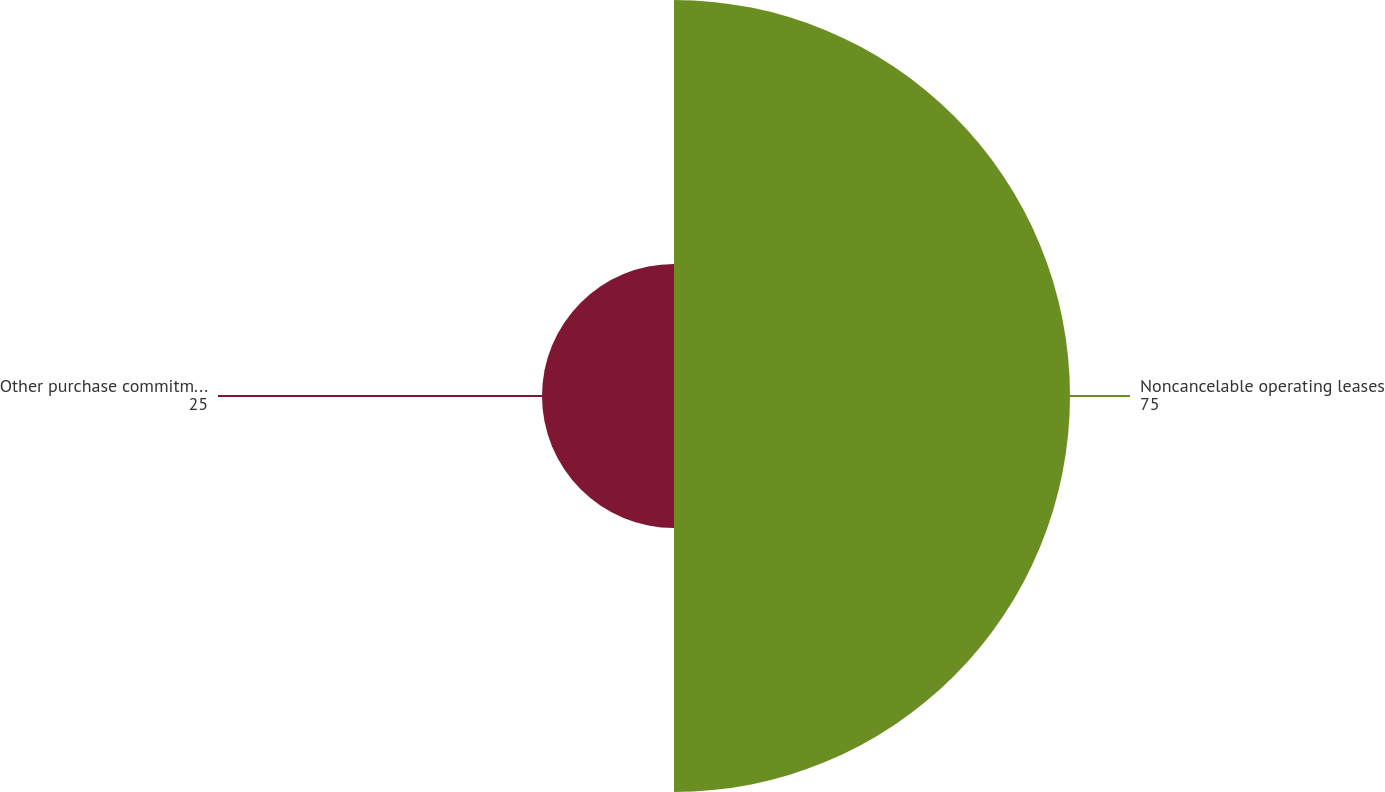Convert chart. <chart><loc_0><loc_0><loc_500><loc_500><pie_chart><fcel>Noncancelable operating leases<fcel>Other purchase commitments<nl><fcel>75.0%<fcel>25.0%<nl></chart> 